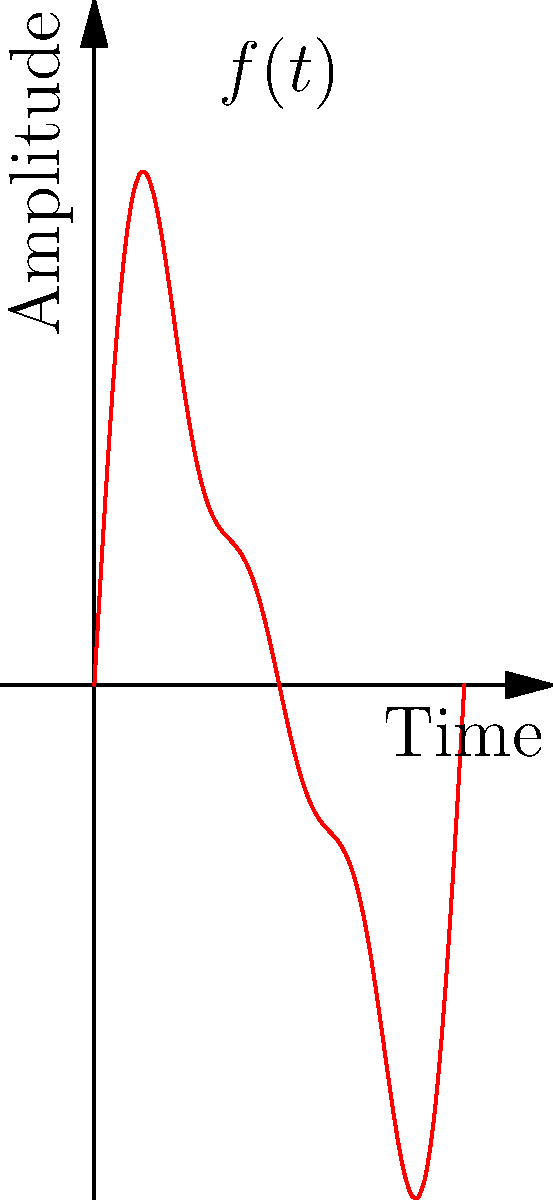The graph above represents a complex waveform $f(t)$ composed of three sinusoidal components. Given that this waveform is expressed as a Fourier series:

$$f(t) = a_1\sin(2\pi t) + a_2\sin(4\pi t) + a_3\sin(6\pi t)$$

Determine the amplitudes $a_1$, $a_2$, and $a_3$ of the individual components. How might understanding this decomposition help in creating a unique sound for a piano composition? To solve this problem, we need to analyze the given Fourier series and compare it with the graph:

1. The Fourier series is given as:
   $$f(t) = a_1\sin(2\pi t) + a_2\sin(4\pi t) + a_3\sin(6\pi t)$$

2. From the graph, we can see that the waveform is a combination of three sine waves with different amplitudes.

3. The first term $a_1\sin(2\pi t)$ represents the fundamental frequency. Its amplitude appears to be the largest, approximately 1.

4. The second term $a_2\sin(4\pi t)$ represents the second harmonic, with double the frequency of the fundamental. Its amplitude appears to be about half of the fundamental, so approximately 0.5.

5. The third term $a_3\sin(6\pi t)$ represents the third harmonic, with triple the frequency of the fundamental. Its amplitude appears to be about half of the second harmonic, so approximately 0.25.

6. Therefore, we can deduce that $a_1 = 1$, $a_2 = 0.5$, and $a_3 = 0.25$.

Understanding this decomposition can help in creating a unique sound for a piano composition in several ways:

a) It allows for precise control over the timbre of a synthesized piano sound by adjusting the amplitudes of different harmonics.

b) It can inspire new compositional techniques by manipulating the harmonic content of notes in real-time during a performance.

c) It provides insight into how different combinations of frequencies create complex tones, which can be used to blend classical piano sounds with other genres or electronic elements.

d) It enables the creation of custom "virtual instruments" that combine characteristics of a piano with other instruments or entirely new sounds.
Answer: $a_1 = 1$, $a_2 = 0.5$, $a_3 = 0.25$ 